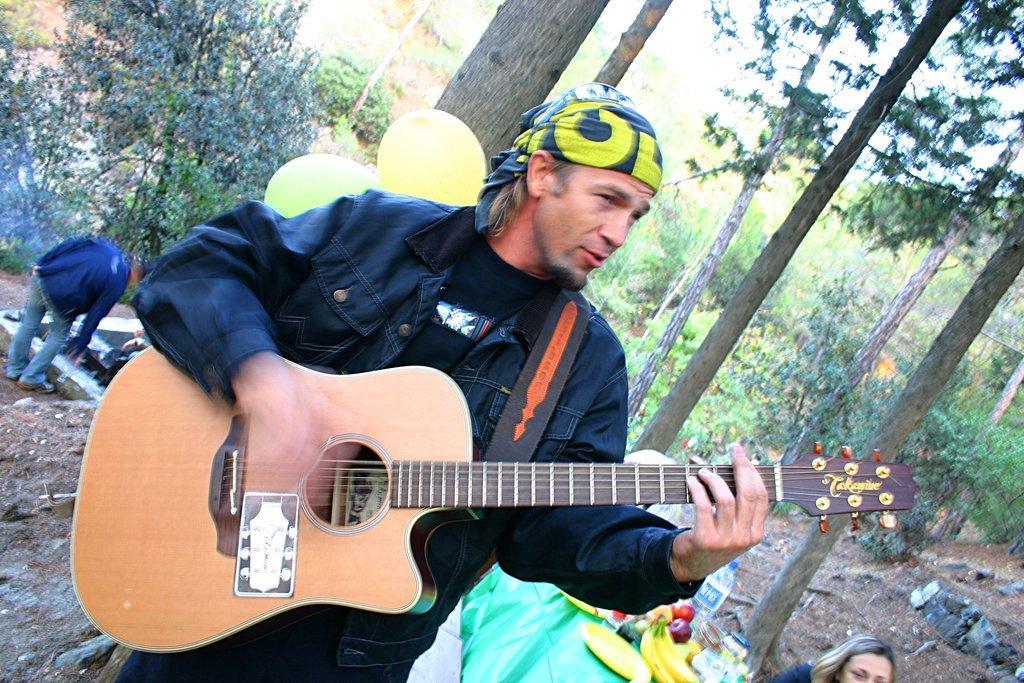Could you give a brief overview of what you see in this image? In this image I can see a three persons. In front the man is playing a guitar. At the background we can see trees and there are food on the table. 